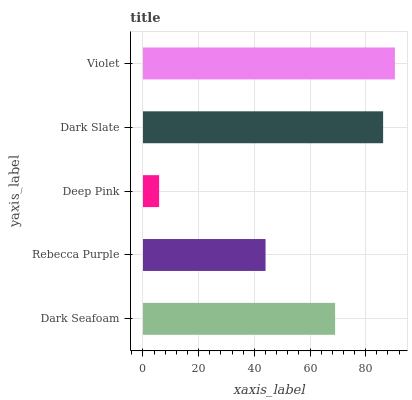Is Deep Pink the minimum?
Answer yes or no. Yes. Is Violet the maximum?
Answer yes or no. Yes. Is Rebecca Purple the minimum?
Answer yes or no. No. Is Rebecca Purple the maximum?
Answer yes or no. No. Is Dark Seafoam greater than Rebecca Purple?
Answer yes or no. Yes. Is Rebecca Purple less than Dark Seafoam?
Answer yes or no. Yes. Is Rebecca Purple greater than Dark Seafoam?
Answer yes or no. No. Is Dark Seafoam less than Rebecca Purple?
Answer yes or no. No. Is Dark Seafoam the high median?
Answer yes or no. Yes. Is Dark Seafoam the low median?
Answer yes or no. Yes. Is Violet the high median?
Answer yes or no. No. Is Deep Pink the low median?
Answer yes or no. No. 